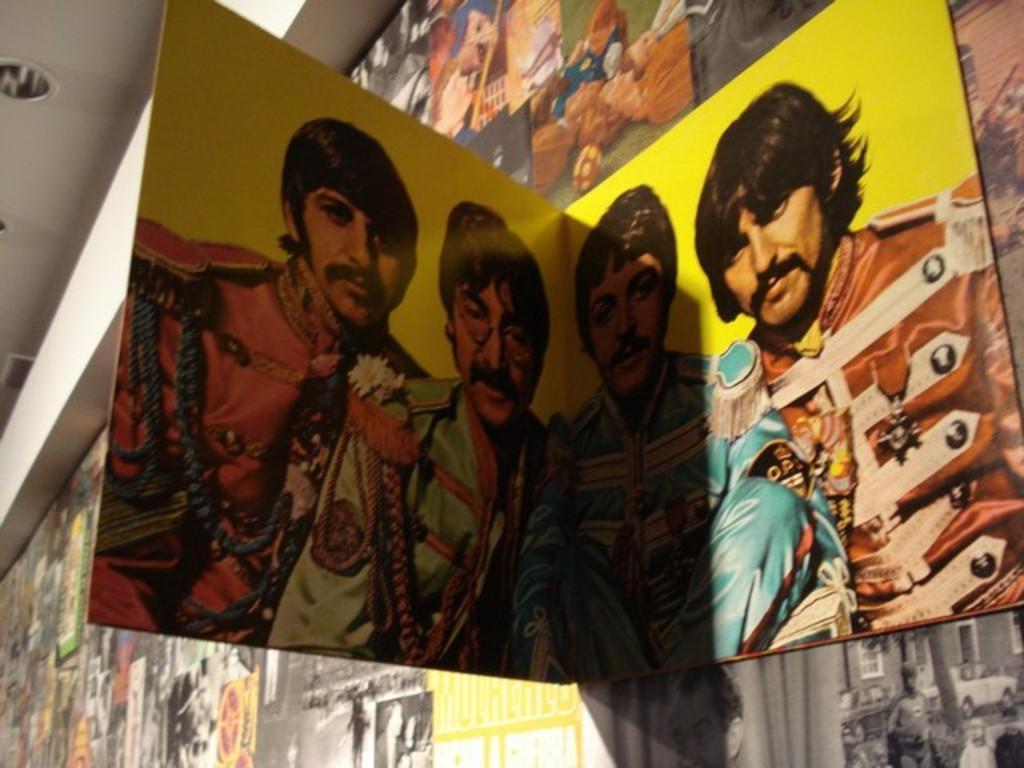Could you give a brief overview of what you see in this image? In the picture we can see a wall with full of photos, paintings and we can also see a board which is yellow in color and two person images on it and to the ceiling we can see the lights. 